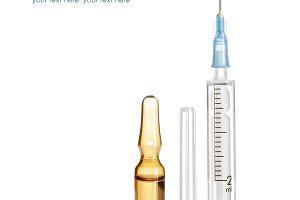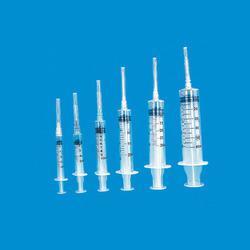The first image is the image on the left, the second image is the image on the right. Given the left and right images, does the statement "There are seven syringes." hold true? Answer yes or no. Yes. The first image is the image on the left, the second image is the image on the right. Analyze the images presented: Is the assertion "There is exactly one syringe with an uncapped needle." valid? Answer yes or no. Yes. 